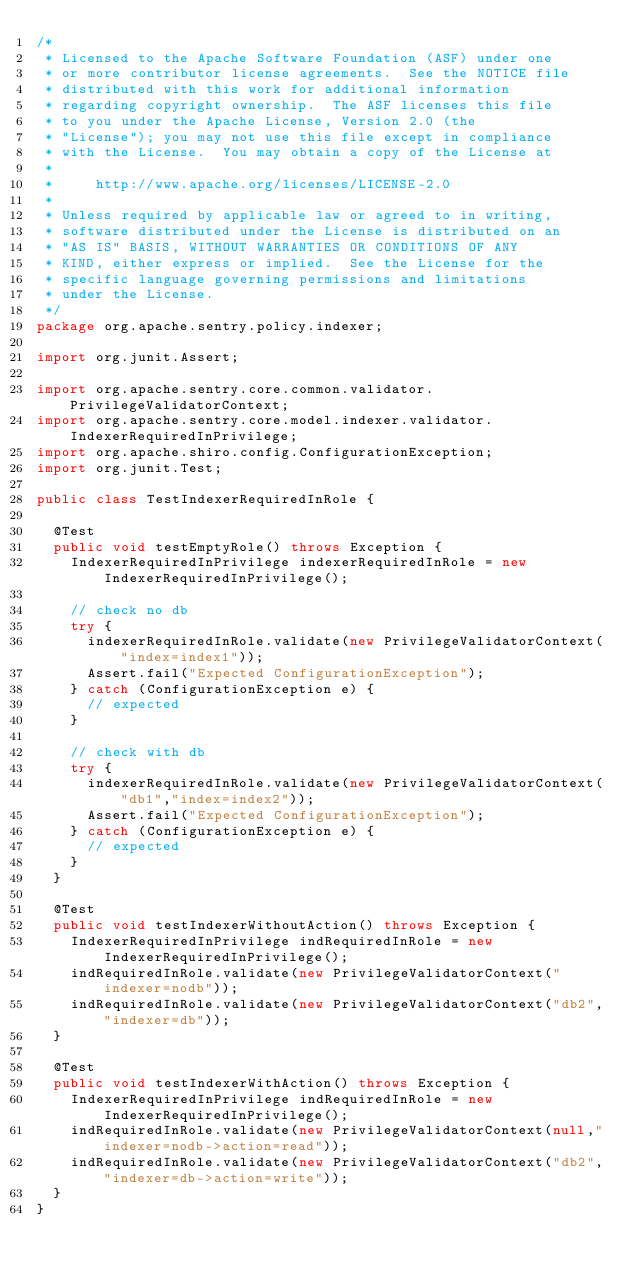Convert code to text. <code><loc_0><loc_0><loc_500><loc_500><_Java_>/*
 * Licensed to the Apache Software Foundation (ASF) under one
 * or more contributor license agreements.  See the NOTICE file
 * distributed with this work for additional information
 * regarding copyright ownership.  The ASF licenses this file
 * to you under the Apache License, Version 2.0 (the
 * "License"); you may not use this file except in compliance
 * with the License.  You may obtain a copy of the License at
 *
 *     http://www.apache.org/licenses/LICENSE-2.0
 *
 * Unless required by applicable law or agreed to in writing,
 * software distributed under the License is distributed on an
 * "AS IS" BASIS, WITHOUT WARRANTIES OR CONDITIONS OF ANY
 * KIND, either express or implied.  See the License for the
 * specific language governing permissions and limitations
 * under the License.
 */
package org.apache.sentry.policy.indexer;

import org.junit.Assert;

import org.apache.sentry.core.common.validator.PrivilegeValidatorContext;
import org.apache.sentry.core.model.indexer.validator.IndexerRequiredInPrivilege;
import org.apache.shiro.config.ConfigurationException;
import org.junit.Test;

public class TestIndexerRequiredInRole {

  @Test
  public void testEmptyRole() throws Exception {
    IndexerRequiredInPrivilege indexerRequiredInRole = new IndexerRequiredInPrivilege();

    // check no db
    try {
      indexerRequiredInRole.validate(new PrivilegeValidatorContext("index=index1"));
      Assert.fail("Expected ConfigurationException");
    } catch (ConfigurationException e) {
      // expected
    }

    // check with db
    try {
      indexerRequiredInRole.validate(new PrivilegeValidatorContext("db1","index=index2"));
      Assert.fail("Expected ConfigurationException");
    } catch (ConfigurationException e) {
      // expected
    }
  }

  @Test
  public void testIndexerWithoutAction() throws Exception {
    IndexerRequiredInPrivilege indRequiredInRole = new IndexerRequiredInPrivilege();
    indRequiredInRole.validate(new PrivilegeValidatorContext("indexer=nodb"));
    indRequiredInRole.validate(new PrivilegeValidatorContext("db2","indexer=db"));
  }

  @Test
  public void testIndexerWithAction() throws Exception {
    IndexerRequiredInPrivilege indRequiredInRole = new IndexerRequiredInPrivilege();
    indRequiredInRole.validate(new PrivilegeValidatorContext(null,"indexer=nodb->action=read"));
    indRequiredInRole.validate(new PrivilegeValidatorContext("db2","indexer=db->action=write"));
  }
}
</code> 